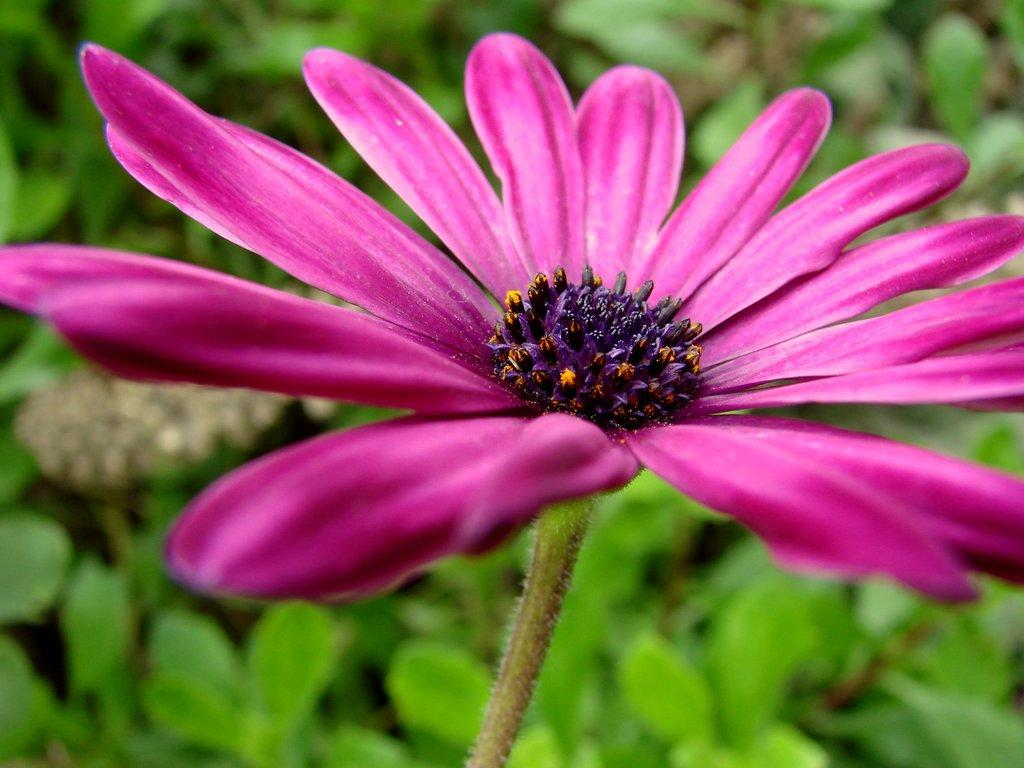What is the color of the flower in the image? The flower in the image is pink. Are there any other colors present on the flower? Yes, the flower has purple color buds. What can be seen in the background of the image? There are plants in the background of the image. What is the color of the plants in the background? The plants in the background are green in color. How far away is the chair from the flower in the image? There is no chair present in the image, so it is not possible to determine the distance between a chair and the flower. 